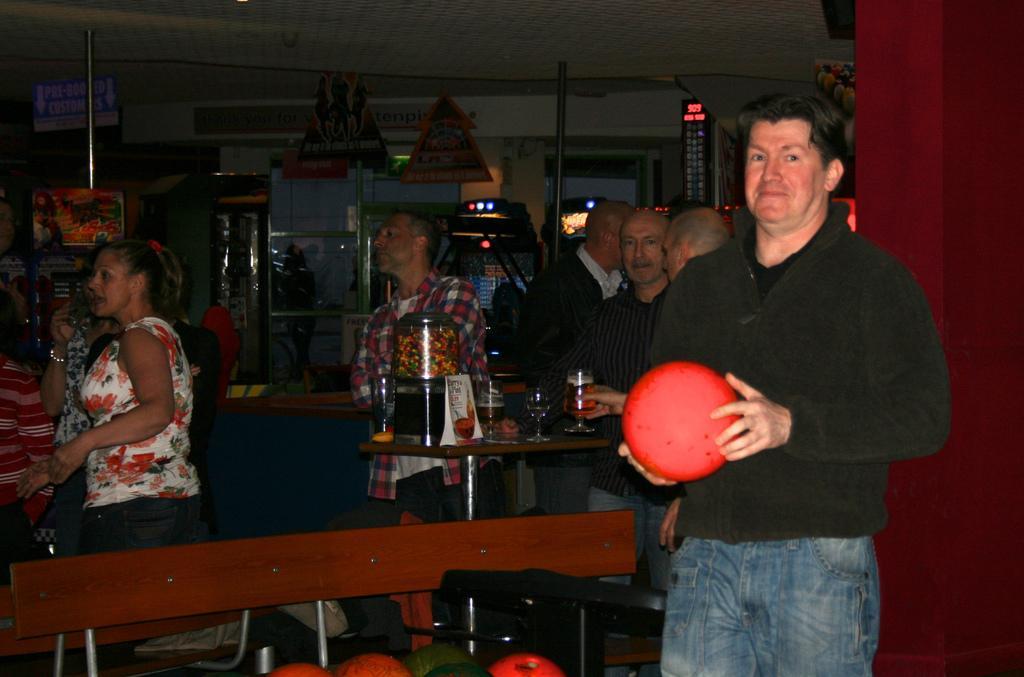Describe this image in one or two sentences. In this image we can see a man holding a red color ball in his hands and standing. In the background we can see few people, glasses on the table and etc. 